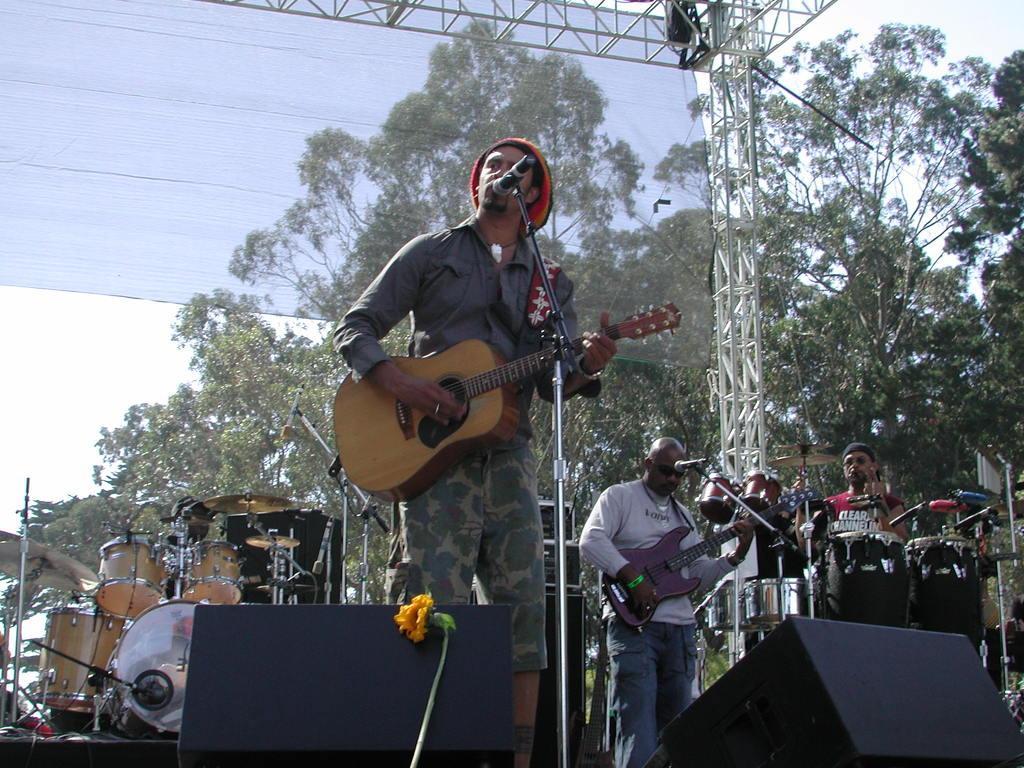Can you describe this image briefly? This picture shows a man standing on the stage holding a guitar in his hand. He is having a mic in front of his mouth and singing. In the background, there are some musical instrument and some people playing those instruments. We can observe some trees, sky and a curtain here. 